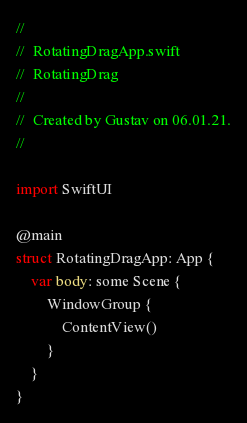<code> <loc_0><loc_0><loc_500><loc_500><_Swift_>//
//  RotatingDragApp.swift
//  RotatingDrag
//
//  Created by Gustav on 06.01.21.
//

import SwiftUI

@main
struct RotatingDragApp: App {
    var body: some Scene {
        WindowGroup {
            ContentView()
        }
    }
}
</code> 